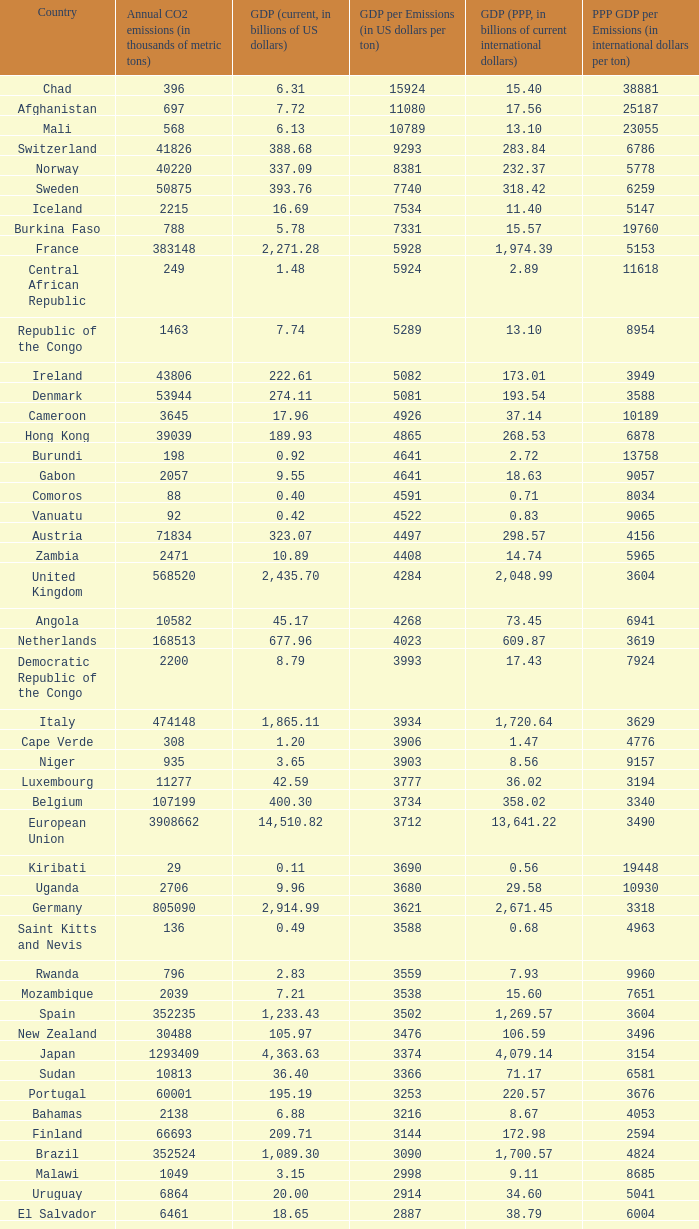50, what is the gdp? 2562.0. 